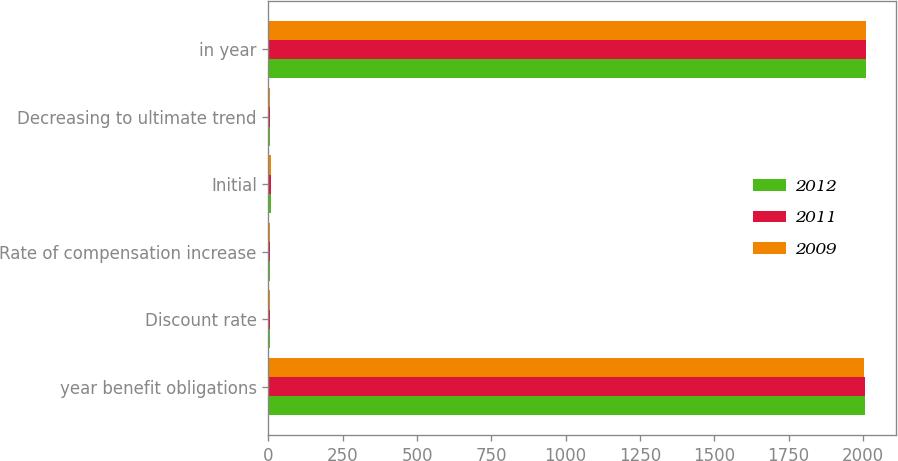Convert chart. <chart><loc_0><loc_0><loc_500><loc_500><stacked_bar_chart><ecel><fcel>year benefit obligations<fcel>Discount rate<fcel>Rate of compensation increase<fcel>Initial<fcel>Decreasing to ultimate trend<fcel>in year<nl><fcel>2012<fcel>2007<fcel>6.19<fcel>3.75<fcel>9<fcel>5<fcel>2012<nl><fcel>2011<fcel>2006<fcel>5.86<fcel>3.75<fcel>9<fcel>5<fcel>2011<nl><fcel>2009<fcel>2005<fcel>5.62<fcel>3.75<fcel>8<fcel>5<fcel>2009<nl></chart> 